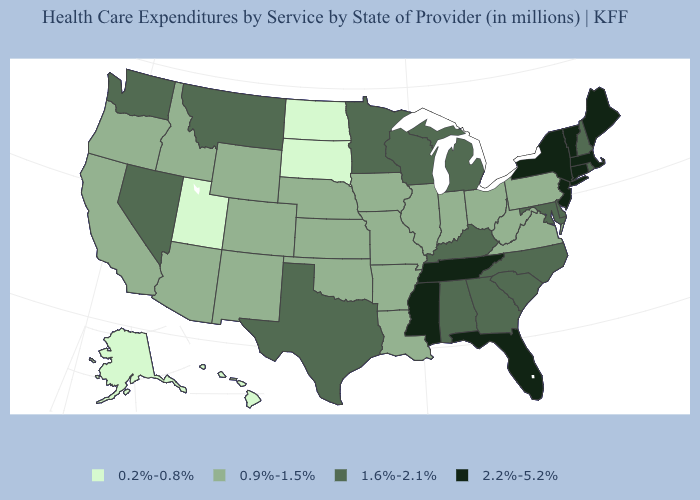Among the states that border Montana , which have the lowest value?
Concise answer only. North Dakota, South Dakota. Among the states that border New Mexico , does Texas have the highest value?
Quick response, please. Yes. Does Alaska have the lowest value in the USA?
Keep it brief. Yes. Among the states that border Virginia , which have the highest value?
Write a very short answer. Tennessee. Name the states that have a value in the range 0.9%-1.5%?
Be succinct. Arizona, Arkansas, California, Colorado, Idaho, Illinois, Indiana, Iowa, Kansas, Louisiana, Missouri, Nebraska, New Mexico, Ohio, Oklahoma, Oregon, Pennsylvania, Virginia, West Virginia, Wyoming. Does Alaska have the highest value in the West?
Short answer required. No. Name the states that have a value in the range 1.6%-2.1%?
Give a very brief answer. Alabama, Delaware, Georgia, Kentucky, Maryland, Michigan, Minnesota, Montana, Nevada, New Hampshire, North Carolina, Rhode Island, South Carolina, Texas, Washington, Wisconsin. Does Rhode Island have the same value as Michigan?
Short answer required. Yes. What is the lowest value in the USA?
Answer briefly. 0.2%-0.8%. What is the value of Oklahoma?
Quick response, please. 0.9%-1.5%. What is the lowest value in states that border California?
Write a very short answer. 0.9%-1.5%. What is the value of New York?
Quick response, please. 2.2%-5.2%. What is the value of Iowa?
Write a very short answer. 0.9%-1.5%. Name the states that have a value in the range 2.2%-5.2%?
Write a very short answer. Connecticut, Florida, Maine, Massachusetts, Mississippi, New Jersey, New York, Tennessee, Vermont. Name the states that have a value in the range 2.2%-5.2%?
Concise answer only. Connecticut, Florida, Maine, Massachusetts, Mississippi, New Jersey, New York, Tennessee, Vermont. 